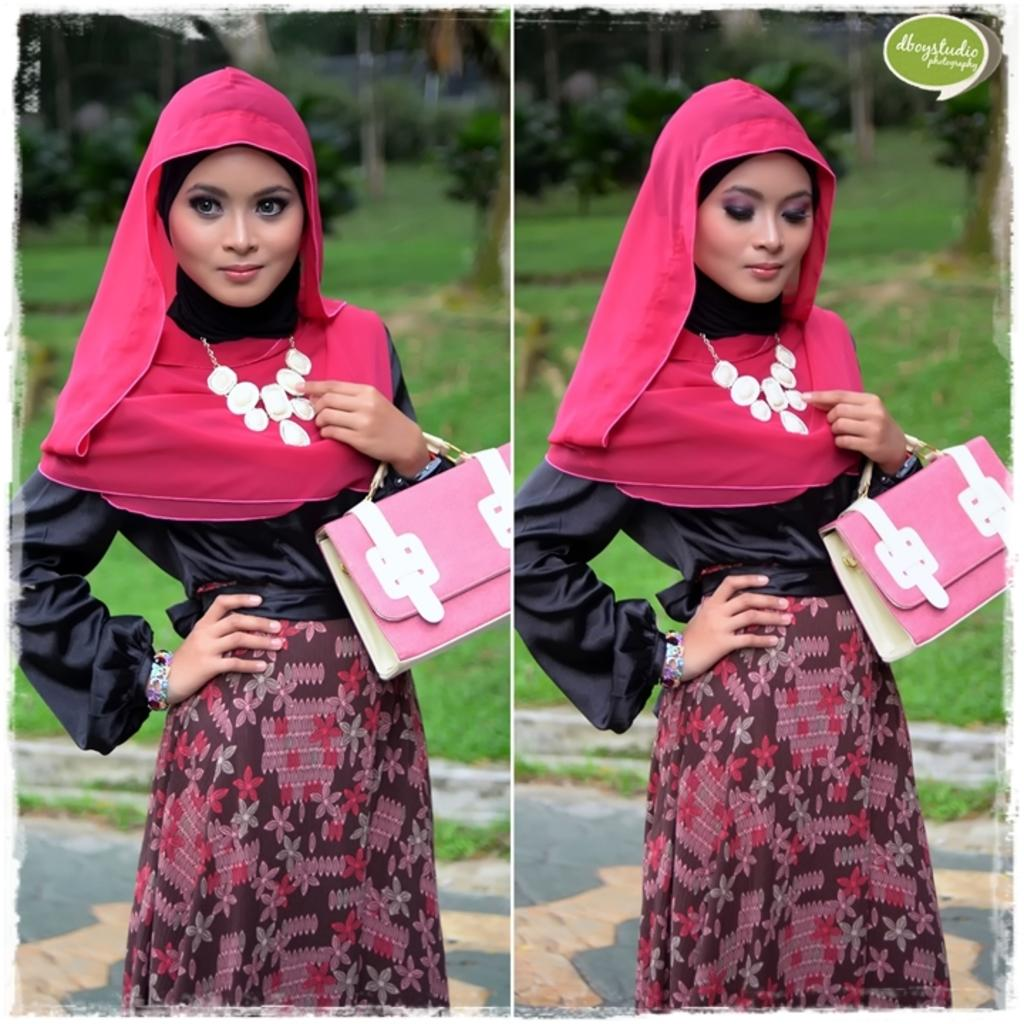Who is the main subject in the image? There is a girl in the image. What is the girl holding in her hand? The girl is holding a bag in her hand. What can be seen in the background of the image? There are trees in the background of the image. What type of yam is the girl using to gain approval from the skate in the image? There is no yam, approval, or skate present in the image. 